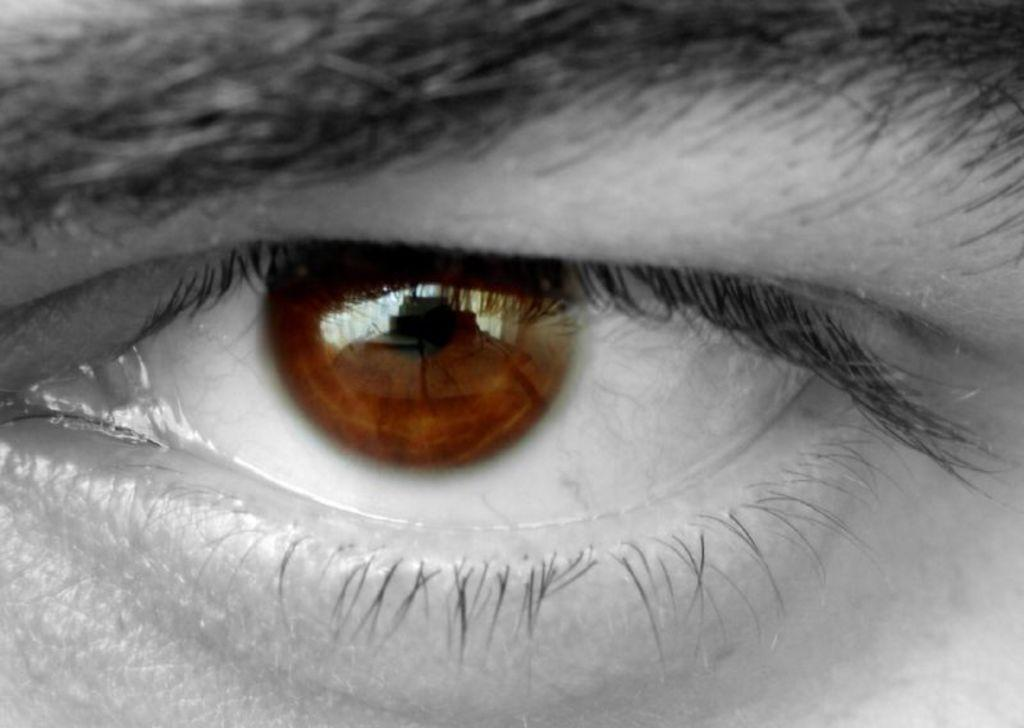What facial feature is present in the image? There is an eyebrow in the image. What body part is associated with the eyebrow? The eyebrow is part of the eye area. What other feature is present in the eye area? There is an eye in the image. What color is the pupil in the eye? The pupil in the eye is brown. What color is the iris in the eye? The iris in the eye is also brown. How many dogs are visible in the image? There are no dogs present in the image. Is there a visitor standing next to the eyebrow in the image? There is no visitor or any other person present in the image; only the eyebrow and eye are visible. 